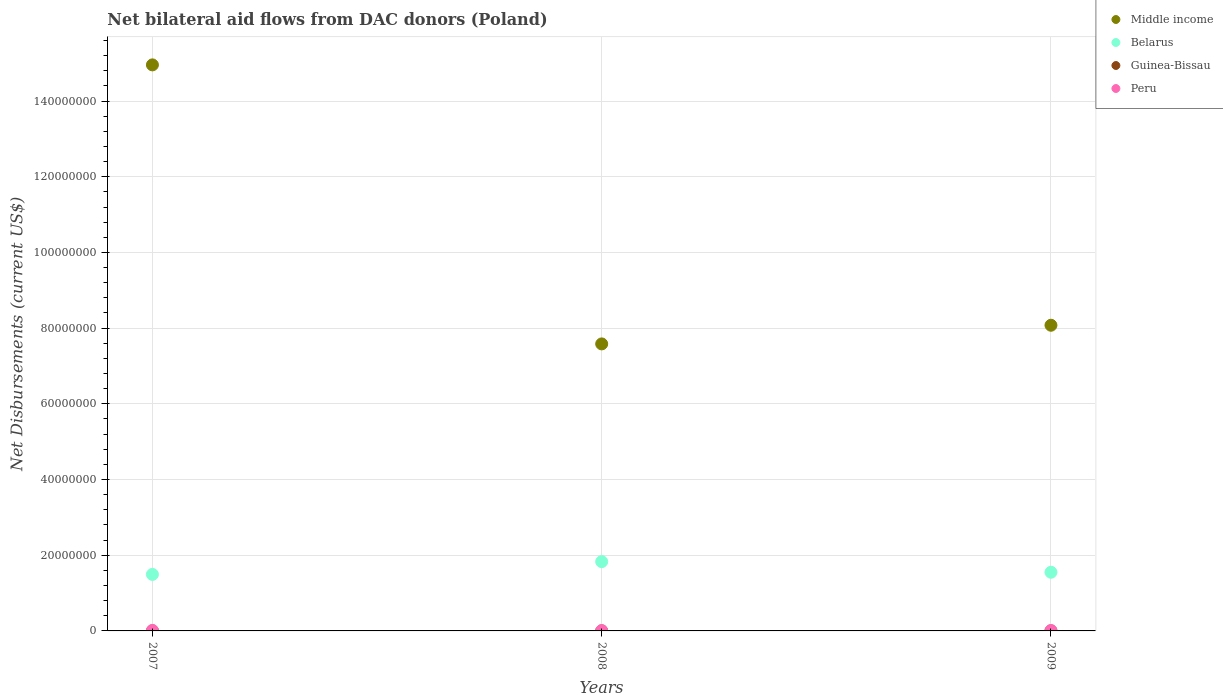How many different coloured dotlines are there?
Keep it short and to the point. 4. Is the number of dotlines equal to the number of legend labels?
Offer a terse response. Yes. Across all years, what is the maximum net bilateral aid flows in Middle income?
Give a very brief answer. 1.50e+08. Across all years, what is the minimum net bilateral aid flows in Guinea-Bissau?
Keep it short and to the point. 10000. What is the difference between the net bilateral aid flows in Peru in 2007 and that in 2008?
Provide a succinct answer. 4.00e+04. What is the difference between the net bilateral aid flows in Guinea-Bissau in 2008 and the net bilateral aid flows in Belarus in 2007?
Provide a succinct answer. -1.49e+07. In the year 2007, what is the difference between the net bilateral aid flows in Middle income and net bilateral aid flows in Peru?
Your response must be concise. 1.49e+08. What is the ratio of the net bilateral aid flows in Middle income in 2008 to that in 2009?
Your answer should be compact. 0.94. What is the difference between the highest and the second highest net bilateral aid flows in Middle income?
Your answer should be very brief. 6.88e+07. What is the difference between the highest and the lowest net bilateral aid flows in Middle income?
Offer a very short reply. 7.37e+07. In how many years, is the net bilateral aid flows in Peru greater than the average net bilateral aid flows in Peru taken over all years?
Your response must be concise. 1. Is it the case that in every year, the sum of the net bilateral aid flows in Belarus and net bilateral aid flows in Middle income  is greater than the net bilateral aid flows in Guinea-Bissau?
Provide a succinct answer. Yes. Does the net bilateral aid flows in Guinea-Bissau monotonically increase over the years?
Your answer should be compact. No. Is the net bilateral aid flows in Belarus strictly less than the net bilateral aid flows in Middle income over the years?
Offer a very short reply. Yes. How many years are there in the graph?
Provide a succinct answer. 3. Does the graph contain grids?
Make the answer very short. Yes. What is the title of the graph?
Provide a succinct answer. Net bilateral aid flows from DAC donors (Poland). Does "Channel Islands" appear as one of the legend labels in the graph?
Make the answer very short. No. What is the label or title of the X-axis?
Ensure brevity in your answer.  Years. What is the label or title of the Y-axis?
Provide a short and direct response. Net Disbursements (current US$). What is the Net Disbursements (current US$) in Middle income in 2007?
Provide a short and direct response. 1.50e+08. What is the Net Disbursements (current US$) of Belarus in 2007?
Provide a succinct answer. 1.49e+07. What is the Net Disbursements (current US$) in Middle income in 2008?
Your response must be concise. 7.58e+07. What is the Net Disbursements (current US$) of Belarus in 2008?
Your response must be concise. 1.83e+07. What is the Net Disbursements (current US$) of Peru in 2008?
Offer a terse response. 9.00e+04. What is the Net Disbursements (current US$) of Middle income in 2009?
Offer a terse response. 8.08e+07. What is the Net Disbursements (current US$) of Belarus in 2009?
Your answer should be compact. 1.55e+07. What is the Net Disbursements (current US$) of Peru in 2009?
Your answer should be very brief. 1.10e+05. Across all years, what is the maximum Net Disbursements (current US$) of Middle income?
Provide a short and direct response. 1.50e+08. Across all years, what is the maximum Net Disbursements (current US$) in Belarus?
Provide a succinct answer. 1.83e+07. Across all years, what is the maximum Net Disbursements (current US$) of Guinea-Bissau?
Provide a succinct answer. 10000. Across all years, what is the maximum Net Disbursements (current US$) of Peru?
Provide a succinct answer. 1.30e+05. Across all years, what is the minimum Net Disbursements (current US$) in Middle income?
Provide a short and direct response. 7.58e+07. Across all years, what is the minimum Net Disbursements (current US$) of Belarus?
Keep it short and to the point. 1.49e+07. Across all years, what is the minimum Net Disbursements (current US$) of Guinea-Bissau?
Your answer should be compact. 10000. What is the total Net Disbursements (current US$) of Middle income in the graph?
Make the answer very short. 3.06e+08. What is the total Net Disbursements (current US$) in Belarus in the graph?
Offer a very short reply. 4.87e+07. What is the total Net Disbursements (current US$) in Peru in the graph?
Make the answer very short. 3.30e+05. What is the difference between the Net Disbursements (current US$) in Middle income in 2007 and that in 2008?
Keep it short and to the point. 7.37e+07. What is the difference between the Net Disbursements (current US$) of Belarus in 2007 and that in 2008?
Make the answer very short. -3.38e+06. What is the difference between the Net Disbursements (current US$) in Guinea-Bissau in 2007 and that in 2008?
Give a very brief answer. 0. What is the difference between the Net Disbursements (current US$) of Middle income in 2007 and that in 2009?
Ensure brevity in your answer.  6.88e+07. What is the difference between the Net Disbursements (current US$) of Belarus in 2007 and that in 2009?
Your answer should be compact. -5.70e+05. What is the difference between the Net Disbursements (current US$) in Guinea-Bissau in 2007 and that in 2009?
Offer a very short reply. 0. What is the difference between the Net Disbursements (current US$) of Middle income in 2008 and that in 2009?
Offer a terse response. -4.93e+06. What is the difference between the Net Disbursements (current US$) in Belarus in 2008 and that in 2009?
Your response must be concise. 2.81e+06. What is the difference between the Net Disbursements (current US$) of Middle income in 2007 and the Net Disbursements (current US$) of Belarus in 2008?
Provide a succinct answer. 1.31e+08. What is the difference between the Net Disbursements (current US$) of Middle income in 2007 and the Net Disbursements (current US$) of Guinea-Bissau in 2008?
Your answer should be very brief. 1.50e+08. What is the difference between the Net Disbursements (current US$) of Middle income in 2007 and the Net Disbursements (current US$) of Peru in 2008?
Give a very brief answer. 1.49e+08. What is the difference between the Net Disbursements (current US$) in Belarus in 2007 and the Net Disbursements (current US$) in Guinea-Bissau in 2008?
Make the answer very short. 1.49e+07. What is the difference between the Net Disbursements (current US$) in Belarus in 2007 and the Net Disbursements (current US$) in Peru in 2008?
Keep it short and to the point. 1.48e+07. What is the difference between the Net Disbursements (current US$) of Middle income in 2007 and the Net Disbursements (current US$) of Belarus in 2009?
Your answer should be very brief. 1.34e+08. What is the difference between the Net Disbursements (current US$) in Middle income in 2007 and the Net Disbursements (current US$) in Guinea-Bissau in 2009?
Give a very brief answer. 1.50e+08. What is the difference between the Net Disbursements (current US$) in Middle income in 2007 and the Net Disbursements (current US$) in Peru in 2009?
Ensure brevity in your answer.  1.49e+08. What is the difference between the Net Disbursements (current US$) in Belarus in 2007 and the Net Disbursements (current US$) in Guinea-Bissau in 2009?
Give a very brief answer. 1.49e+07. What is the difference between the Net Disbursements (current US$) in Belarus in 2007 and the Net Disbursements (current US$) in Peru in 2009?
Ensure brevity in your answer.  1.48e+07. What is the difference between the Net Disbursements (current US$) of Guinea-Bissau in 2007 and the Net Disbursements (current US$) of Peru in 2009?
Make the answer very short. -1.00e+05. What is the difference between the Net Disbursements (current US$) of Middle income in 2008 and the Net Disbursements (current US$) of Belarus in 2009?
Give a very brief answer. 6.03e+07. What is the difference between the Net Disbursements (current US$) of Middle income in 2008 and the Net Disbursements (current US$) of Guinea-Bissau in 2009?
Offer a terse response. 7.58e+07. What is the difference between the Net Disbursements (current US$) of Middle income in 2008 and the Net Disbursements (current US$) of Peru in 2009?
Ensure brevity in your answer.  7.57e+07. What is the difference between the Net Disbursements (current US$) in Belarus in 2008 and the Net Disbursements (current US$) in Guinea-Bissau in 2009?
Offer a terse response. 1.83e+07. What is the difference between the Net Disbursements (current US$) in Belarus in 2008 and the Net Disbursements (current US$) in Peru in 2009?
Provide a succinct answer. 1.82e+07. What is the average Net Disbursements (current US$) in Middle income per year?
Keep it short and to the point. 1.02e+08. What is the average Net Disbursements (current US$) of Belarus per year?
Provide a succinct answer. 1.62e+07. What is the average Net Disbursements (current US$) in Guinea-Bissau per year?
Make the answer very short. 10000. In the year 2007, what is the difference between the Net Disbursements (current US$) of Middle income and Net Disbursements (current US$) of Belarus?
Make the answer very short. 1.35e+08. In the year 2007, what is the difference between the Net Disbursements (current US$) of Middle income and Net Disbursements (current US$) of Guinea-Bissau?
Your answer should be compact. 1.50e+08. In the year 2007, what is the difference between the Net Disbursements (current US$) of Middle income and Net Disbursements (current US$) of Peru?
Offer a terse response. 1.49e+08. In the year 2007, what is the difference between the Net Disbursements (current US$) in Belarus and Net Disbursements (current US$) in Guinea-Bissau?
Offer a very short reply. 1.49e+07. In the year 2007, what is the difference between the Net Disbursements (current US$) in Belarus and Net Disbursements (current US$) in Peru?
Provide a short and direct response. 1.48e+07. In the year 2007, what is the difference between the Net Disbursements (current US$) in Guinea-Bissau and Net Disbursements (current US$) in Peru?
Provide a short and direct response. -1.20e+05. In the year 2008, what is the difference between the Net Disbursements (current US$) of Middle income and Net Disbursements (current US$) of Belarus?
Keep it short and to the point. 5.75e+07. In the year 2008, what is the difference between the Net Disbursements (current US$) in Middle income and Net Disbursements (current US$) in Guinea-Bissau?
Ensure brevity in your answer.  7.58e+07. In the year 2008, what is the difference between the Net Disbursements (current US$) of Middle income and Net Disbursements (current US$) of Peru?
Provide a short and direct response. 7.57e+07. In the year 2008, what is the difference between the Net Disbursements (current US$) of Belarus and Net Disbursements (current US$) of Guinea-Bissau?
Provide a succinct answer. 1.83e+07. In the year 2008, what is the difference between the Net Disbursements (current US$) of Belarus and Net Disbursements (current US$) of Peru?
Offer a very short reply. 1.82e+07. In the year 2008, what is the difference between the Net Disbursements (current US$) in Guinea-Bissau and Net Disbursements (current US$) in Peru?
Your response must be concise. -8.00e+04. In the year 2009, what is the difference between the Net Disbursements (current US$) in Middle income and Net Disbursements (current US$) in Belarus?
Provide a short and direct response. 6.53e+07. In the year 2009, what is the difference between the Net Disbursements (current US$) in Middle income and Net Disbursements (current US$) in Guinea-Bissau?
Your answer should be compact. 8.08e+07. In the year 2009, what is the difference between the Net Disbursements (current US$) of Middle income and Net Disbursements (current US$) of Peru?
Keep it short and to the point. 8.06e+07. In the year 2009, what is the difference between the Net Disbursements (current US$) in Belarus and Net Disbursements (current US$) in Guinea-Bissau?
Provide a succinct answer. 1.55e+07. In the year 2009, what is the difference between the Net Disbursements (current US$) of Belarus and Net Disbursements (current US$) of Peru?
Provide a succinct answer. 1.54e+07. What is the ratio of the Net Disbursements (current US$) in Middle income in 2007 to that in 2008?
Your answer should be compact. 1.97. What is the ratio of the Net Disbursements (current US$) in Belarus in 2007 to that in 2008?
Provide a succinct answer. 0.82. What is the ratio of the Net Disbursements (current US$) in Guinea-Bissau in 2007 to that in 2008?
Keep it short and to the point. 1. What is the ratio of the Net Disbursements (current US$) of Peru in 2007 to that in 2008?
Your answer should be very brief. 1.44. What is the ratio of the Net Disbursements (current US$) of Middle income in 2007 to that in 2009?
Provide a short and direct response. 1.85. What is the ratio of the Net Disbursements (current US$) in Belarus in 2007 to that in 2009?
Offer a terse response. 0.96. What is the ratio of the Net Disbursements (current US$) of Peru in 2007 to that in 2009?
Offer a terse response. 1.18. What is the ratio of the Net Disbursements (current US$) of Middle income in 2008 to that in 2009?
Make the answer very short. 0.94. What is the ratio of the Net Disbursements (current US$) of Belarus in 2008 to that in 2009?
Keep it short and to the point. 1.18. What is the ratio of the Net Disbursements (current US$) of Guinea-Bissau in 2008 to that in 2009?
Provide a short and direct response. 1. What is the ratio of the Net Disbursements (current US$) of Peru in 2008 to that in 2009?
Make the answer very short. 0.82. What is the difference between the highest and the second highest Net Disbursements (current US$) in Middle income?
Offer a terse response. 6.88e+07. What is the difference between the highest and the second highest Net Disbursements (current US$) in Belarus?
Keep it short and to the point. 2.81e+06. What is the difference between the highest and the second highest Net Disbursements (current US$) of Peru?
Ensure brevity in your answer.  2.00e+04. What is the difference between the highest and the lowest Net Disbursements (current US$) in Middle income?
Provide a short and direct response. 7.37e+07. What is the difference between the highest and the lowest Net Disbursements (current US$) of Belarus?
Keep it short and to the point. 3.38e+06. What is the difference between the highest and the lowest Net Disbursements (current US$) of Peru?
Make the answer very short. 4.00e+04. 